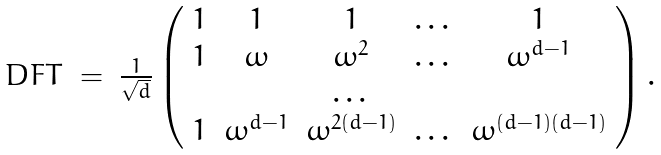<formula> <loc_0><loc_0><loc_500><loc_500>\begin{array} { l c c } D F T & = & \frac { 1 } { \sqrt { d } } \left ( \begin{array} { c c c c c } 1 & 1 & 1 & \dots & 1 \\ 1 & \omega & \omega ^ { 2 } & \dots & \omega ^ { d - 1 } \\ & & \dots & \\ 1 & \omega ^ { d - 1 } & \omega ^ { 2 ( d - 1 ) } & \dots & \omega ^ { ( d - 1 ) ( d - 1 ) } \end{array} \right ) . \end{array}</formula> 